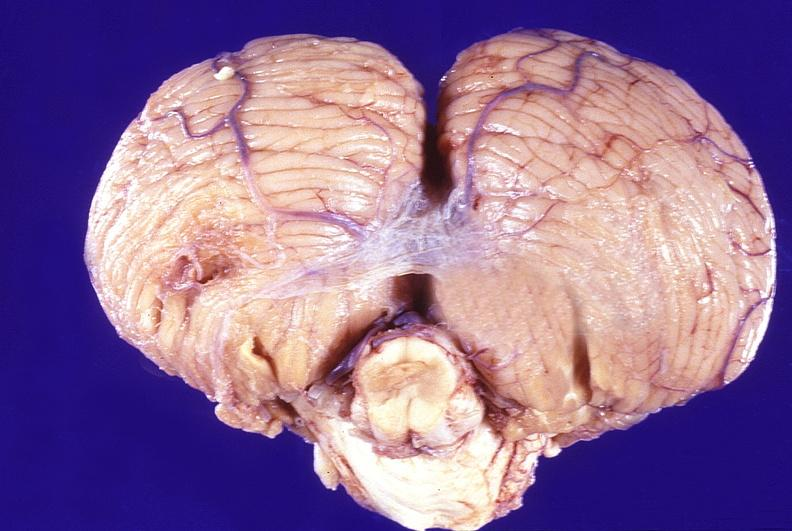does this image show normal brain?
Answer the question using a single word or phrase. Yes 